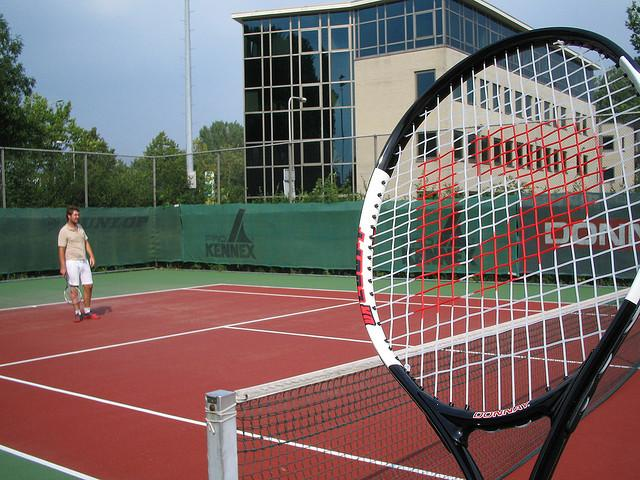Who plays this sport? Please explain your reasoning. serena williams. Serena williams is famous for playing tennis. 